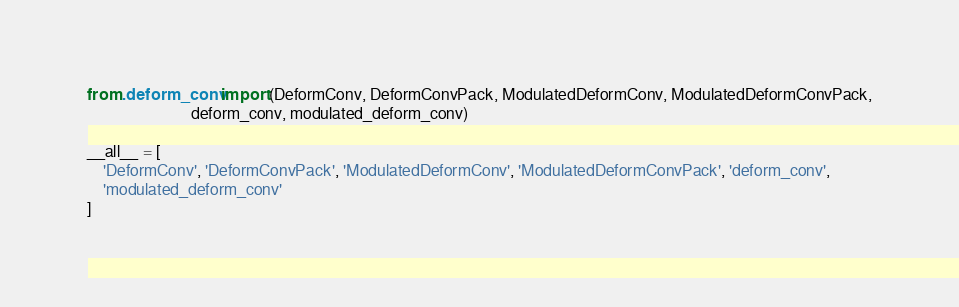<code> <loc_0><loc_0><loc_500><loc_500><_Python_>from .deform_conv import (DeformConv, DeformConvPack, ModulatedDeformConv, ModulatedDeformConvPack,
                          deform_conv, modulated_deform_conv)

__all__ = [
    'DeformConv', 'DeformConvPack', 'ModulatedDeformConv', 'ModulatedDeformConvPack', 'deform_conv',
    'modulated_deform_conv'
]
</code> 